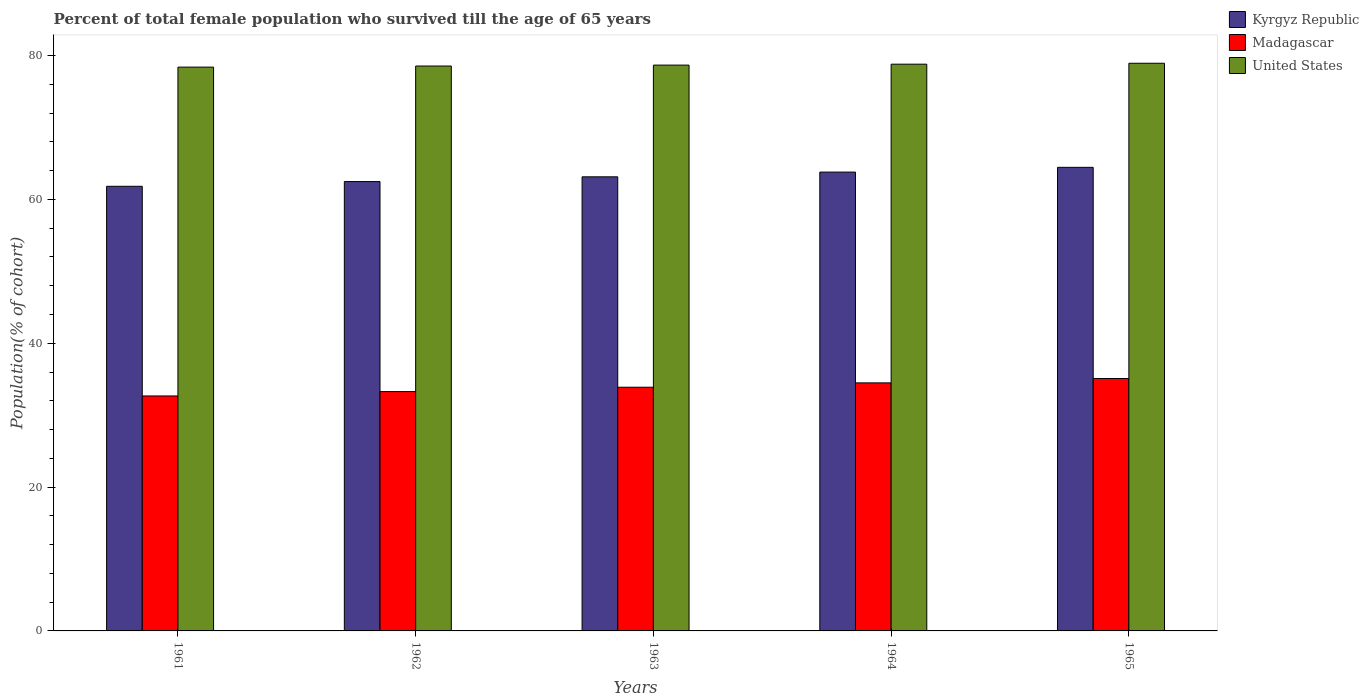How many groups of bars are there?
Ensure brevity in your answer.  5. How many bars are there on the 1st tick from the right?
Keep it short and to the point. 3. What is the label of the 1st group of bars from the left?
Your answer should be very brief. 1961. In how many cases, is the number of bars for a given year not equal to the number of legend labels?
Provide a succinct answer. 0. What is the percentage of total female population who survived till the age of 65 years in Kyrgyz Republic in 1962?
Your answer should be very brief. 62.48. Across all years, what is the maximum percentage of total female population who survived till the age of 65 years in Kyrgyz Republic?
Ensure brevity in your answer.  64.46. Across all years, what is the minimum percentage of total female population who survived till the age of 65 years in Madagascar?
Provide a succinct answer. 32.67. In which year was the percentage of total female population who survived till the age of 65 years in Kyrgyz Republic maximum?
Keep it short and to the point. 1965. In which year was the percentage of total female population who survived till the age of 65 years in United States minimum?
Ensure brevity in your answer.  1961. What is the total percentage of total female population who survived till the age of 65 years in United States in the graph?
Your response must be concise. 393.37. What is the difference between the percentage of total female population who survived till the age of 65 years in Kyrgyz Republic in 1962 and that in 1964?
Your answer should be compact. -1.32. What is the difference between the percentage of total female population who survived till the age of 65 years in Madagascar in 1965 and the percentage of total female population who survived till the age of 65 years in Kyrgyz Republic in 1961?
Provide a short and direct response. -26.73. What is the average percentage of total female population who survived till the age of 65 years in United States per year?
Your response must be concise. 78.67. In the year 1964, what is the difference between the percentage of total female population who survived till the age of 65 years in United States and percentage of total female population who survived till the age of 65 years in Kyrgyz Republic?
Your response must be concise. 15. In how many years, is the percentage of total female population who survived till the age of 65 years in Kyrgyz Republic greater than 20 %?
Offer a terse response. 5. What is the ratio of the percentage of total female population who survived till the age of 65 years in United States in 1961 to that in 1963?
Your answer should be very brief. 1. What is the difference between the highest and the second highest percentage of total female population who survived till the age of 65 years in Kyrgyz Republic?
Provide a short and direct response. 0.66. What is the difference between the highest and the lowest percentage of total female population who survived till the age of 65 years in United States?
Offer a terse response. 0.54. In how many years, is the percentage of total female population who survived till the age of 65 years in Kyrgyz Republic greater than the average percentage of total female population who survived till the age of 65 years in Kyrgyz Republic taken over all years?
Offer a terse response. 2. What does the 2nd bar from the left in 1963 represents?
Provide a succinct answer. Madagascar. What does the 3rd bar from the right in 1962 represents?
Provide a succinct answer. Kyrgyz Republic. Is it the case that in every year, the sum of the percentage of total female population who survived till the age of 65 years in Kyrgyz Republic and percentage of total female population who survived till the age of 65 years in United States is greater than the percentage of total female population who survived till the age of 65 years in Madagascar?
Give a very brief answer. Yes. What is the difference between two consecutive major ticks on the Y-axis?
Your response must be concise. 20. Are the values on the major ticks of Y-axis written in scientific E-notation?
Provide a short and direct response. No. Does the graph contain any zero values?
Make the answer very short. No. Does the graph contain grids?
Offer a terse response. No. How many legend labels are there?
Make the answer very short. 3. How are the legend labels stacked?
Provide a succinct answer. Vertical. What is the title of the graph?
Offer a terse response. Percent of total female population who survived till the age of 65 years. What is the label or title of the Y-axis?
Give a very brief answer. Population(% of cohort). What is the Population(% of cohort) of Kyrgyz Republic in 1961?
Provide a short and direct response. 61.83. What is the Population(% of cohort) in Madagascar in 1961?
Your response must be concise. 32.67. What is the Population(% of cohort) in United States in 1961?
Offer a terse response. 78.4. What is the Population(% of cohort) in Kyrgyz Republic in 1962?
Provide a succinct answer. 62.48. What is the Population(% of cohort) in Madagascar in 1962?
Your answer should be very brief. 33.28. What is the Population(% of cohort) of United States in 1962?
Provide a succinct answer. 78.55. What is the Population(% of cohort) in Kyrgyz Republic in 1963?
Keep it short and to the point. 63.14. What is the Population(% of cohort) of Madagascar in 1963?
Make the answer very short. 33.89. What is the Population(% of cohort) of United States in 1963?
Ensure brevity in your answer.  78.68. What is the Population(% of cohort) of Kyrgyz Republic in 1964?
Provide a succinct answer. 63.8. What is the Population(% of cohort) in Madagascar in 1964?
Your response must be concise. 34.49. What is the Population(% of cohort) of United States in 1964?
Ensure brevity in your answer.  78.81. What is the Population(% of cohort) of Kyrgyz Republic in 1965?
Provide a short and direct response. 64.46. What is the Population(% of cohort) in Madagascar in 1965?
Offer a terse response. 35.1. What is the Population(% of cohort) of United States in 1965?
Give a very brief answer. 78.94. Across all years, what is the maximum Population(% of cohort) of Kyrgyz Republic?
Ensure brevity in your answer.  64.46. Across all years, what is the maximum Population(% of cohort) of Madagascar?
Offer a terse response. 35.1. Across all years, what is the maximum Population(% of cohort) of United States?
Make the answer very short. 78.94. Across all years, what is the minimum Population(% of cohort) in Kyrgyz Republic?
Ensure brevity in your answer.  61.83. Across all years, what is the minimum Population(% of cohort) of Madagascar?
Your answer should be compact. 32.67. Across all years, what is the minimum Population(% of cohort) in United States?
Offer a terse response. 78.4. What is the total Population(% of cohort) of Kyrgyz Republic in the graph?
Keep it short and to the point. 315.72. What is the total Population(% of cohort) of Madagascar in the graph?
Provide a succinct answer. 169.43. What is the total Population(% of cohort) in United States in the graph?
Make the answer very short. 393.37. What is the difference between the Population(% of cohort) in Kyrgyz Republic in 1961 and that in 1962?
Offer a terse response. -0.66. What is the difference between the Population(% of cohort) of Madagascar in 1961 and that in 1962?
Your answer should be compact. -0.61. What is the difference between the Population(% of cohort) of United States in 1961 and that in 1962?
Offer a very short reply. -0.15. What is the difference between the Population(% of cohort) of Kyrgyz Republic in 1961 and that in 1963?
Keep it short and to the point. -1.32. What is the difference between the Population(% of cohort) in Madagascar in 1961 and that in 1963?
Offer a terse response. -1.21. What is the difference between the Population(% of cohort) in United States in 1961 and that in 1963?
Provide a short and direct response. -0.28. What is the difference between the Population(% of cohort) in Kyrgyz Republic in 1961 and that in 1964?
Your answer should be compact. -1.98. What is the difference between the Population(% of cohort) in Madagascar in 1961 and that in 1964?
Ensure brevity in your answer.  -1.82. What is the difference between the Population(% of cohort) of United States in 1961 and that in 1964?
Your answer should be compact. -0.41. What is the difference between the Population(% of cohort) in Kyrgyz Republic in 1961 and that in 1965?
Provide a succinct answer. -2.64. What is the difference between the Population(% of cohort) in Madagascar in 1961 and that in 1965?
Give a very brief answer. -2.42. What is the difference between the Population(% of cohort) in United States in 1961 and that in 1965?
Your answer should be very brief. -0.54. What is the difference between the Population(% of cohort) of Kyrgyz Republic in 1962 and that in 1963?
Your answer should be very brief. -0.66. What is the difference between the Population(% of cohort) in Madagascar in 1962 and that in 1963?
Offer a terse response. -0.6. What is the difference between the Population(% of cohort) in United States in 1962 and that in 1963?
Provide a short and direct response. -0.13. What is the difference between the Population(% of cohort) of Kyrgyz Republic in 1962 and that in 1964?
Make the answer very short. -1.32. What is the difference between the Population(% of cohort) of Madagascar in 1962 and that in 1964?
Provide a short and direct response. -1.21. What is the difference between the Population(% of cohort) of United States in 1962 and that in 1964?
Your answer should be compact. -0.26. What is the difference between the Population(% of cohort) of Kyrgyz Republic in 1962 and that in 1965?
Ensure brevity in your answer.  -1.98. What is the difference between the Population(% of cohort) in Madagascar in 1962 and that in 1965?
Provide a short and direct response. -1.81. What is the difference between the Population(% of cohort) in United States in 1962 and that in 1965?
Your answer should be very brief. -0.39. What is the difference between the Population(% of cohort) of Kyrgyz Republic in 1963 and that in 1964?
Keep it short and to the point. -0.66. What is the difference between the Population(% of cohort) in Madagascar in 1963 and that in 1964?
Your answer should be very brief. -0.6. What is the difference between the Population(% of cohort) of United States in 1963 and that in 1964?
Your answer should be very brief. -0.13. What is the difference between the Population(% of cohort) in Kyrgyz Republic in 1963 and that in 1965?
Ensure brevity in your answer.  -1.32. What is the difference between the Population(% of cohort) of Madagascar in 1963 and that in 1965?
Your answer should be very brief. -1.21. What is the difference between the Population(% of cohort) in United States in 1963 and that in 1965?
Your answer should be very brief. -0.26. What is the difference between the Population(% of cohort) of Kyrgyz Republic in 1964 and that in 1965?
Make the answer very short. -0.66. What is the difference between the Population(% of cohort) of Madagascar in 1964 and that in 1965?
Provide a succinct answer. -0.6. What is the difference between the Population(% of cohort) of United States in 1964 and that in 1965?
Ensure brevity in your answer.  -0.13. What is the difference between the Population(% of cohort) of Kyrgyz Republic in 1961 and the Population(% of cohort) of Madagascar in 1962?
Make the answer very short. 28.55. What is the difference between the Population(% of cohort) in Kyrgyz Republic in 1961 and the Population(% of cohort) in United States in 1962?
Provide a succinct answer. -16.72. What is the difference between the Population(% of cohort) in Madagascar in 1961 and the Population(% of cohort) in United States in 1962?
Provide a short and direct response. -45.88. What is the difference between the Population(% of cohort) of Kyrgyz Republic in 1961 and the Population(% of cohort) of Madagascar in 1963?
Give a very brief answer. 27.94. What is the difference between the Population(% of cohort) in Kyrgyz Republic in 1961 and the Population(% of cohort) in United States in 1963?
Your response must be concise. -16.85. What is the difference between the Population(% of cohort) in Madagascar in 1961 and the Population(% of cohort) in United States in 1963?
Provide a short and direct response. -46.01. What is the difference between the Population(% of cohort) in Kyrgyz Republic in 1961 and the Population(% of cohort) in Madagascar in 1964?
Give a very brief answer. 27.34. What is the difference between the Population(% of cohort) in Kyrgyz Republic in 1961 and the Population(% of cohort) in United States in 1964?
Your answer should be very brief. -16.98. What is the difference between the Population(% of cohort) in Madagascar in 1961 and the Population(% of cohort) in United States in 1964?
Ensure brevity in your answer.  -46.13. What is the difference between the Population(% of cohort) in Kyrgyz Republic in 1961 and the Population(% of cohort) in Madagascar in 1965?
Your response must be concise. 26.73. What is the difference between the Population(% of cohort) in Kyrgyz Republic in 1961 and the Population(% of cohort) in United States in 1965?
Provide a succinct answer. -17.11. What is the difference between the Population(% of cohort) of Madagascar in 1961 and the Population(% of cohort) of United States in 1965?
Offer a very short reply. -46.26. What is the difference between the Population(% of cohort) of Kyrgyz Republic in 1962 and the Population(% of cohort) of Madagascar in 1963?
Offer a very short reply. 28.6. What is the difference between the Population(% of cohort) of Kyrgyz Republic in 1962 and the Population(% of cohort) of United States in 1963?
Your response must be concise. -16.19. What is the difference between the Population(% of cohort) of Madagascar in 1962 and the Population(% of cohort) of United States in 1963?
Provide a succinct answer. -45.4. What is the difference between the Population(% of cohort) in Kyrgyz Republic in 1962 and the Population(% of cohort) in Madagascar in 1964?
Your answer should be compact. 27.99. What is the difference between the Population(% of cohort) of Kyrgyz Republic in 1962 and the Population(% of cohort) of United States in 1964?
Offer a terse response. -16.32. What is the difference between the Population(% of cohort) of Madagascar in 1962 and the Population(% of cohort) of United States in 1964?
Provide a succinct answer. -45.53. What is the difference between the Population(% of cohort) in Kyrgyz Republic in 1962 and the Population(% of cohort) in Madagascar in 1965?
Your response must be concise. 27.39. What is the difference between the Population(% of cohort) in Kyrgyz Republic in 1962 and the Population(% of cohort) in United States in 1965?
Your response must be concise. -16.45. What is the difference between the Population(% of cohort) of Madagascar in 1962 and the Population(% of cohort) of United States in 1965?
Keep it short and to the point. -45.65. What is the difference between the Population(% of cohort) in Kyrgyz Republic in 1963 and the Population(% of cohort) in Madagascar in 1964?
Offer a very short reply. 28.65. What is the difference between the Population(% of cohort) of Kyrgyz Republic in 1963 and the Population(% of cohort) of United States in 1964?
Your answer should be very brief. -15.66. What is the difference between the Population(% of cohort) in Madagascar in 1963 and the Population(% of cohort) in United States in 1964?
Provide a succinct answer. -44.92. What is the difference between the Population(% of cohort) of Kyrgyz Republic in 1963 and the Population(% of cohort) of Madagascar in 1965?
Provide a succinct answer. 28.05. What is the difference between the Population(% of cohort) in Kyrgyz Republic in 1963 and the Population(% of cohort) in United States in 1965?
Offer a terse response. -15.79. What is the difference between the Population(% of cohort) in Madagascar in 1963 and the Population(% of cohort) in United States in 1965?
Provide a succinct answer. -45.05. What is the difference between the Population(% of cohort) in Kyrgyz Republic in 1964 and the Population(% of cohort) in Madagascar in 1965?
Your response must be concise. 28.71. What is the difference between the Population(% of cohort) of Kyrgyz Republic in 1964 and the Population(% of cohort) of United States in 1965?
Your response must be concise. -15.13. What is the difference between the Population(% of cohort) in Madagascar in 1964 and the Population(% of cohort) in United States in 1965?
Provide a short and direct response. -44.44. What is the average Population(% of cohort) in Kyrgyz Republic per year?
Make the answer very short. 63.14. What is the average Population(% of cohort) in Madagascar per year?
Give a very brief answer. 33.89. What is the average Population(% of cohort) of United States per year?
Ensure brevity in your answer.  78.67. In the year 1961, what is the difference between the Population(% of cohort) of Kyrgyz Republic and Population(% of cohort) of Madagascar?
Make the answer very short. 29.15. In the year 1961, what is the difference between the Population(% of cohort) in Kyrgyz Republic and Population(% of cohort) in United States?
Make the answer very short. -16.57. In the year 1961, what is the difference between the Population(% of cohort) of Madagascar and Population(% of cohort) of United States?
Your answer should be compact. -45.73. In the year 1962, what is the difference between the Population(% of cohort) in Kyrgyz Republic and Population(% of cohort) in Madagascar?
Give a very brief answer. 29.2. In the year 1962, what is the difference between the Population(% of cohort) of Kyrgyz Republic and Population(% of cohort) of United States?
Your answer should be compact. -16.07. In the year 1962, what is the difference between the Population(% of cohort) of Madagascar and Population(% of cohort) of United States?
Ensure brevity in your answer.  -45.27. In the year 1963, what is the difference between the Population(% of cohort) in Kyrgyz Republic and Population(% of cohort) in Madagascar?
Offer a terse response. 29.26. In the year 1963, what is the difference between the Population(% of cohort) in Kyrgyz Republic and Population(% of cohort) in United States?
Offer a very short reply. -15.53. In the year 1963, what is the difference between the Population(% of cohort) of Madagascar and Population(% of cohort) of United States?
Your answer should be compact. -44.79. In the year 1964, what is the difference between the Population(% of cohort) in Kyrgyz Republic and Population(% of cohort) in Madagascar?
Provide a succinct answer. 29.31. In the year 1964, what is the difference between the Population(% of cohort) in Kyrgyz Republic and Population(% of cohort) in United States?
Give a very brief answer. -15. In the year 1964, what is the difference between the Population(% of cohort) in Madagascar and Population(% of cohort) in United States?
Provide a short and direct response. -44.32. In the year 1965, what is the difference between the Population(% of cohort) of Kyrgyz Republic and Population(% of cohort) of Madagascar?
Give a very brief answer. 29.37. In the year 1965, what is the difference between the Population(% of cohort) in Kyrgyz Republic and Population(% of cohort) in United States?
Give a very brief answer. -14.47. In the year 1965, what is the difference between the Population(% of cohort) in Madagascar and Population(% of cohort) in United States?
Provide a succinct answer. -43.84. What is the ratio of the Population(% of cohort) in Madagascar in 1961 to that in 1962?
Provide a short and direct response. 0.98. What is the ratio of the Population(% of cohort) of Kyrgyz Republic in 1961 to that in 1963?
Keep it short and to the point. 0.98. What is the ratio of the Population(% of cohort) of Madagascar in 1961 to that in 1963?
Your answer should be compact. 0.96. What is the ratio of the Population(% of cohort) of Madagascar in 1961 to that in 1964?
Provide a short and direct response. 0.95. What is the ratio of the Population(% of cohort) of United States in 1961 to that in 1964?
Provide a short and direct response. 0.99. What is the ratio of the Population(% of cohort) in Kyrgyz Republic in 1961 to that in 1965?
Provide a short and direct response. 0.96. What is the ratio of the Population(% of cohort) of Madagascar in 1961 to that in 1965?
Ensure brevity in your answer.  0.93. What is the ratio of the Population(% of cohort) in United States in 1961 to that in 1965?
Your answer should be compact. 0.99. What is the ratio of the Population(% of cohort) in Kyrgyz Republic in 1962 to that in 1963?
Make the answer very short. 0.99. What is the ratio of the Population(% of cohort) in Madagascar in 1962 to that in 1963?
Keep it short and to the point. 0.98. What is the ratio of the Population(% of cohort) in United States in 1962 to that in 1963?
Give a very brief answer. 1. What is the ratio of the Population(% of cohort) of Kyrgyz Republic in 1962 to that in 1964?
Offer a terse response. 0.98. What is the ratio of the Population(% of cohort) of Madagascar in 1962 to that in 1964?
Ensure brevity in your answer.  0.96. What is the ratio of the Population(% of cohort) of United States in 1962 to that in 1964?
Keep it short and to the point. 1. What is the ratio of the Population(% of cohort) of Kyrgyz Republic in 1962 to that in 1965?
Offer a very short reply. 0.97. What is the ratio of the Population(% of cohort) of Madagascar in 1962 to that in 1965?
Provide a succinct answer. 0.95. What is the ratio of the Population(% of cohort) in Madagascar in 1963 to that in 1964?
Your answer should be compact. 0.98. What is the ratio of the Population(% of cohort) in United States in 1963 to that in 1964?
Offer a terse response. 1. What is the ratio of the Population(% of cohort) in Kyrgyz Republic in 1963 to that in 1965?
Your answer should be very brief. 0.98. What is the ratio of the Population(% of cohort) of Madagascar in 1963 to that in 1965?
Make the answer very short. 0.97. What is the ratio of the Population(% of cohort) of United States in 1963 to that in 1965?
Your response must be concise. 1. What is the ratio of the Population(% of cohort) in Madagascar in 1964 to that in 1965?
Make the answer very short. 0.98. What is the ratio of the Population(% of cohort) in United States in 1964 to that in 1965?
Provide a succinct answer. 1. What is the difference between the highest and the second highest Population(% of cohort) of Kyrgyz Republic?
Your answer should be very brief. 0.66. What is the difference between the highest and the second highest Population(% of cohort) in Madagascar?
Provide a short and direct response. 0.6. What is the difference between the highest and the second highest Population(% of cohort) in United States?
Keep it short and to the point. 0.13. What is the difference between the highest and the lowest Population(% of cohort) of Kyrgyz Republic?
Keep it short and to the point. 2.64. What is the difference between the highest and the lowest Population(% of cohort) of Madagascar?
Your answer should be very brief. 2.42. What is the difference between the highest and the lowest Population(% of cohort) in United States?
Your answer should be compact. 0.54. 